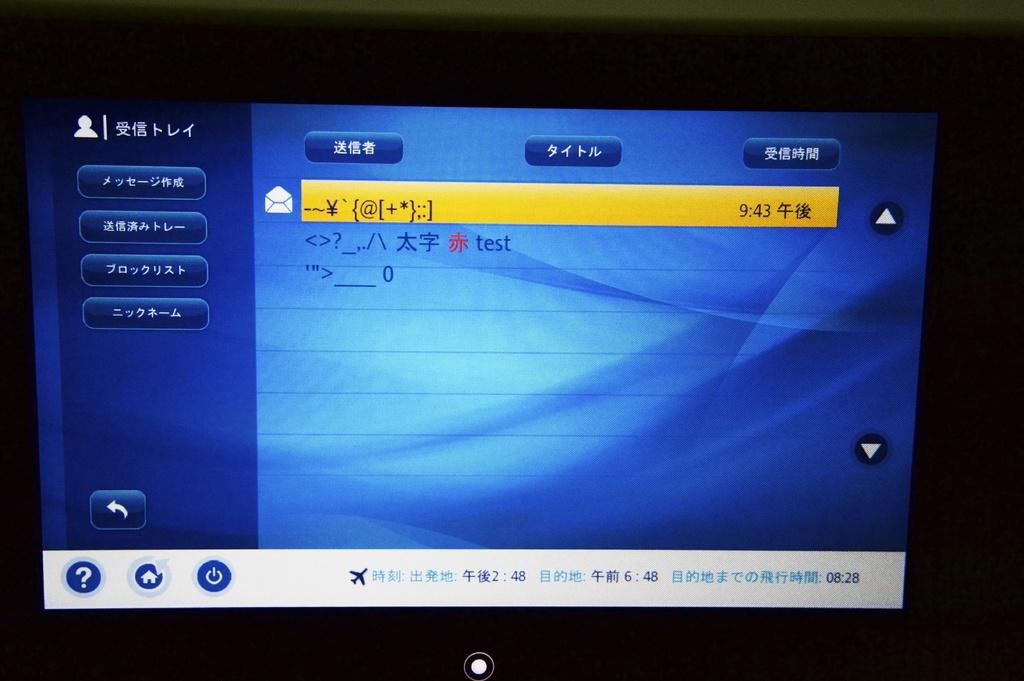<image>
Present a compact description of the photo's key features. a mostly blue screen with a yellow bar stating the time of 943 